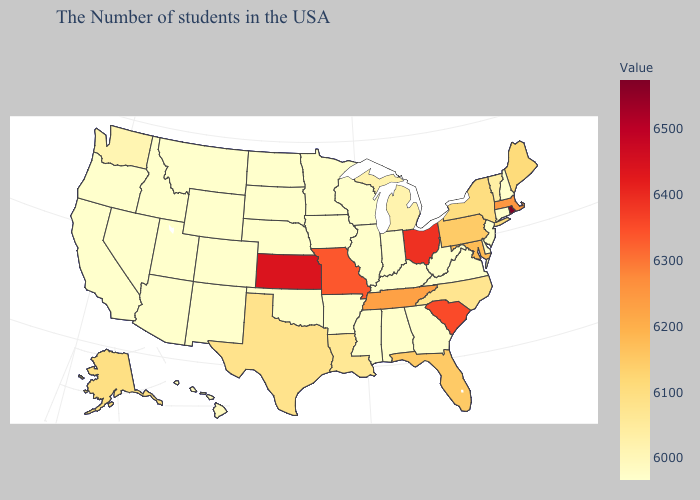Does South Carolina have the highest value in the South?
Keep it brief. Yes. Does the map have missing data?
Answer briefly. No. Which states have the lowest value in the USA?
Concise answer only. New Hampshire, Connecticut, New Jersey, Delaware, Virginia, West Virginia, Georgia, Kentucky, Indiana, Alabama, Wisconsin, Illinois, Mississippi, Arkansas, Minnesota, Iowa, Oklahoma, South Dakota, North Dakota, Wyoming, Colorado, New Mexico, Utah, Montana, Arizona, Idaho, Nevada, California, Oregon. Which states hav the highest value in the South?
Keep it brief. South Carolina. 